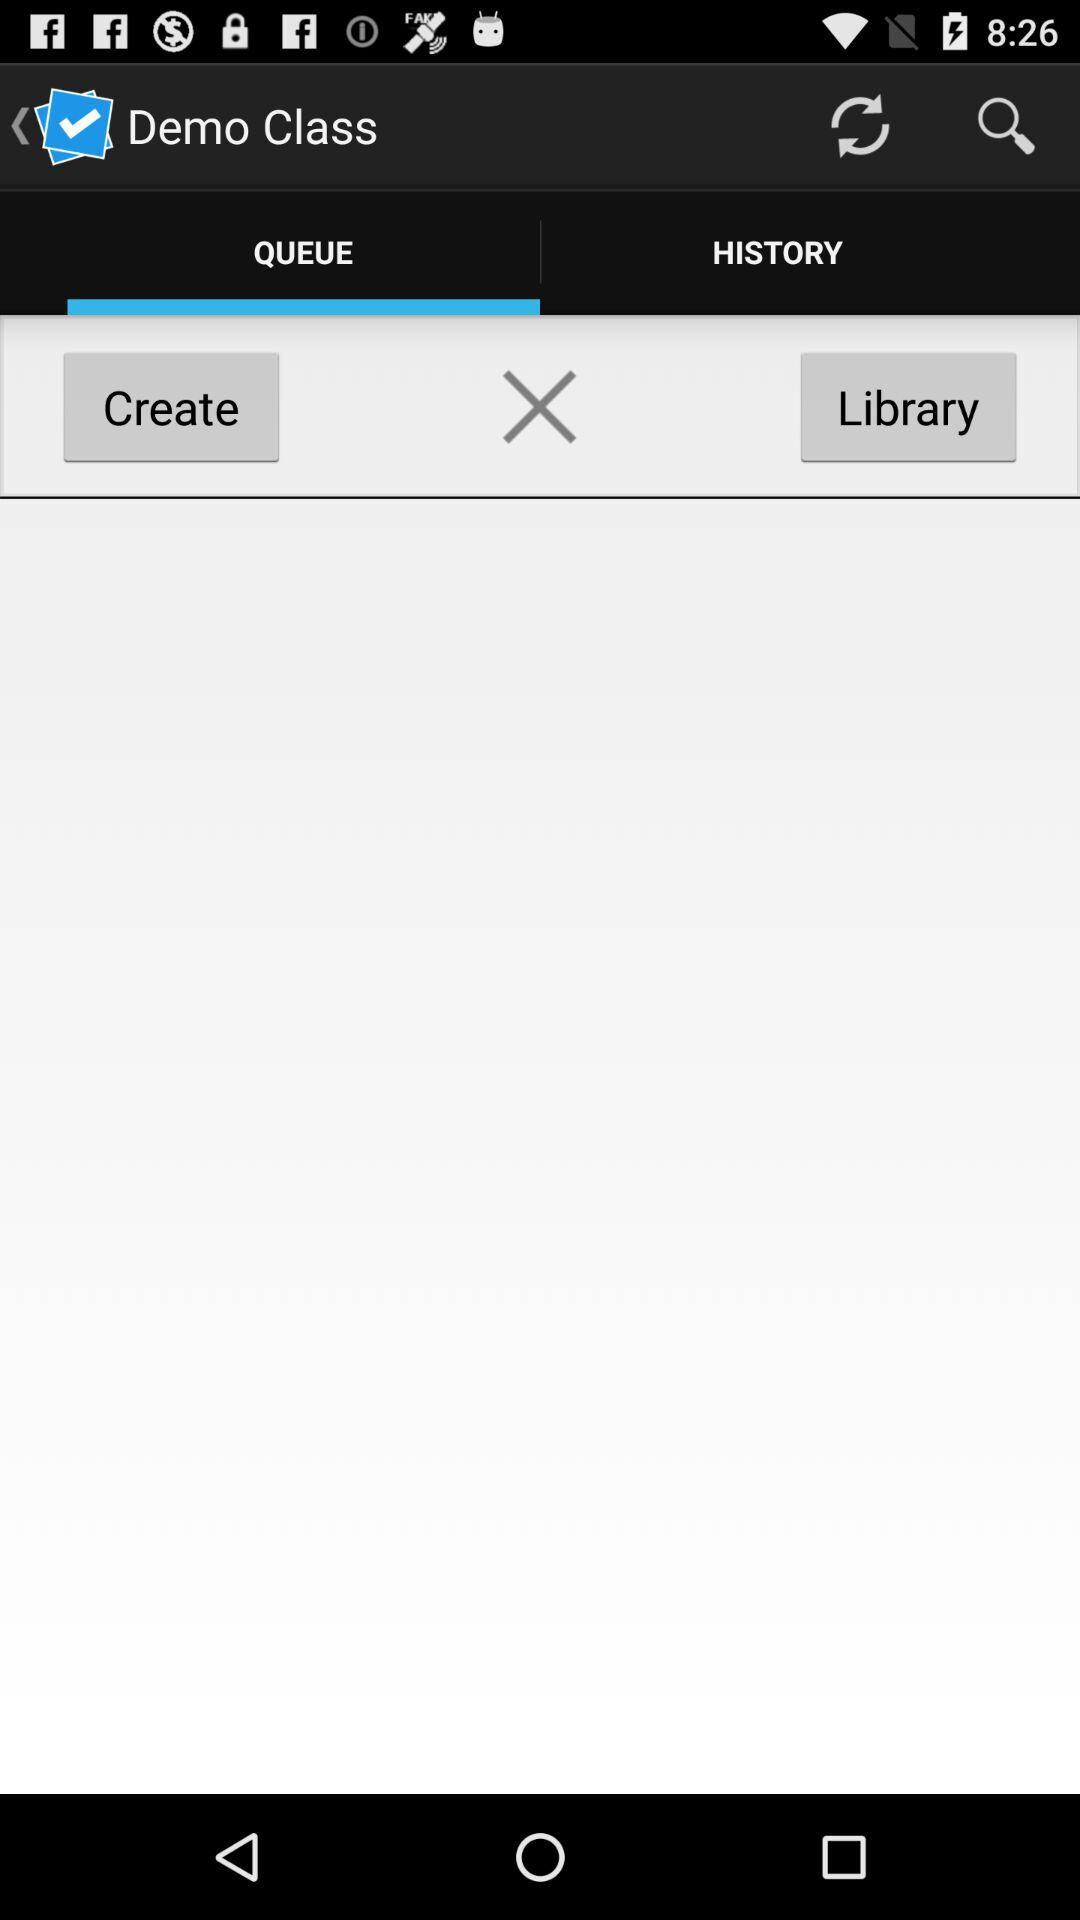Which tab is open? The open tab is "QUEUE". 